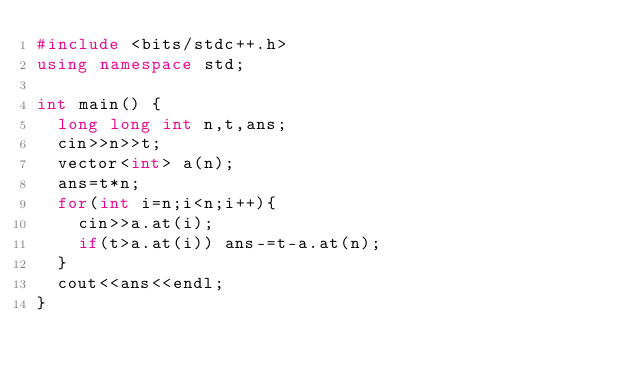<code> <loc_0><loc_0><loc_500><loc_500><_C++_>#include <bits/stdc++.h>
using namespace std;

int main() {
  long long int n,t,ans;
  cin>>n>>t;
  vector<int> a(n);
  ans=t*n;
  for(int i=n;i<n;i++){
    cin>>a.at(i);  
    if(t>a.at(i)) ans-=t-a.at(n);
  }
  cout<<ans<<endl;
}</code> 